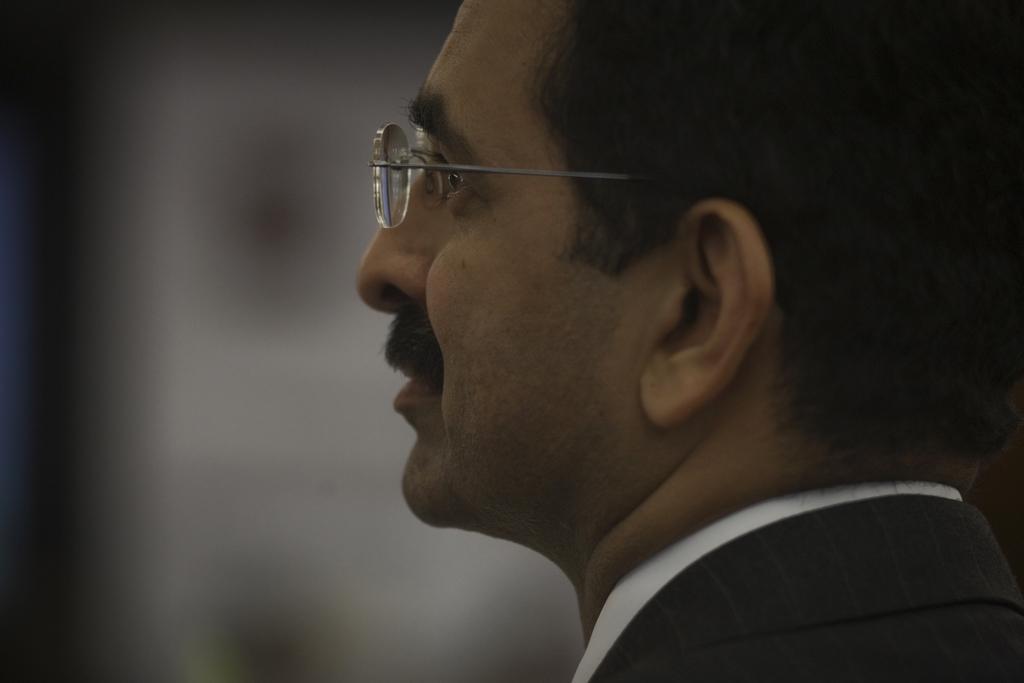Can you describe this image briefly? On the right side of the image a man is there and wearing spectacles. In the background the image is blur. 